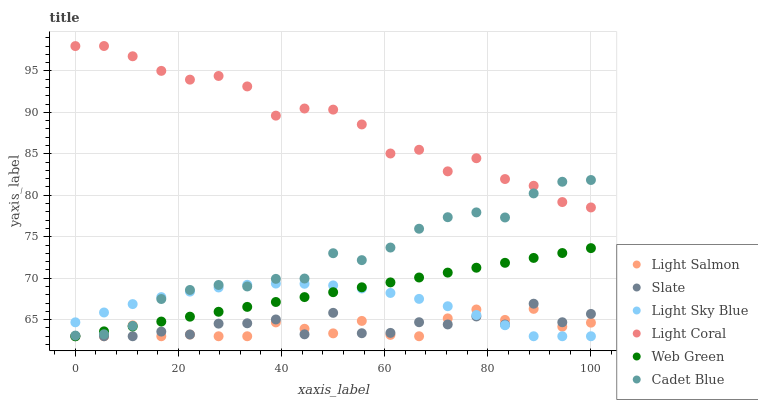Does Light Salmon have the minimum area under the curve?
Answer yes or no. Yes. Does Light Coral have the maximum area under the curve?
Answer yes or no. Yes. Does Cadet Blue have the minimum area under the curve?
Answer yes or no. No. Does Cadet Blue have the maximum area under the curve?
Answer yes or no. No. Is Web Green the smoothest?
Answer yes or no. Yes. Is Slate the roughest?
Answer yes or no. Yes. Is Cadet Blue the smoothest?
Answer yes or no. No. Is Cadet Blue the roughest?
Answer yes or no. No. Does Light Salmon have the lowest value?
Answer yes or no. Yes. Does Cadet Blue have the lowest value?
Answer yes or no. No. Does Light Coral have the highest value?
Answer yes or no. Yes. Does Cadet Blue have the highest value?
Answer yes or no. No. Is Light Salmon less than Light Coral?
Answer yes or no. Yes. Is Light Coral greater than Light Sky Blue?
Answer yes or no. Yes. Does Web Green intersect Light Salmon?
Answer yes or no. Yes. Is Web Green less than Light Salmon?
Answer yes or no. No. Is Web Green greater than Light Salmon?
Answer yes or no. No. Does Light Salmon intersect Light Coral?
Answer yes or no. No. 